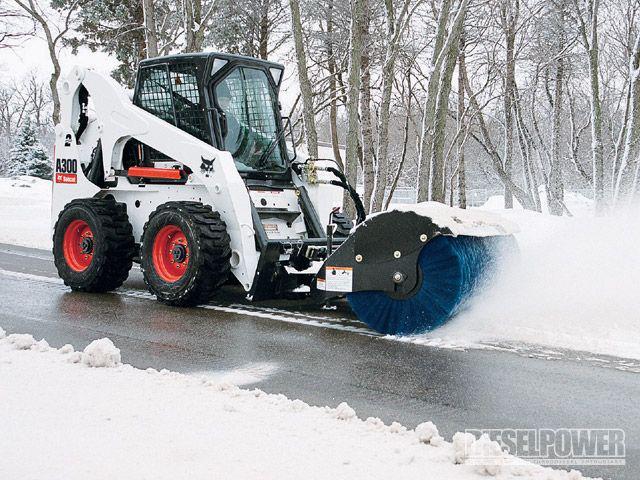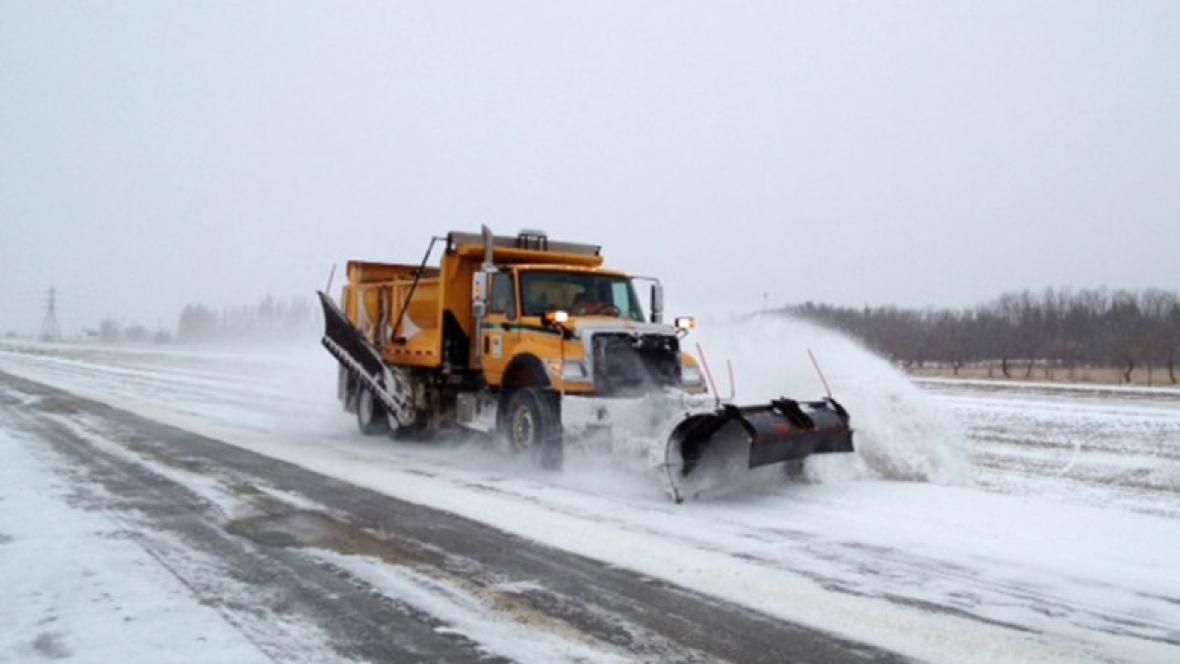The first image is the image on the left, the second image is the image on the right. Assess this claim about the two images: "There is exactly one yellow truck on the image.". Correct or not? Answer yes or no. Yes. 